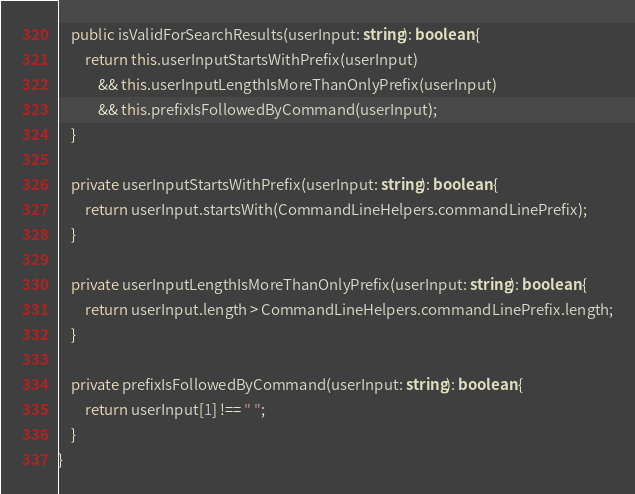<code> <loc_0><loc_0><loc_500><loc_500><_TypeScript_>    public isValidForSearchResults(userInput: string): boolean {
        return this.userInputStartsWithPrefix(userInput)
            && this.userInputLengthIsMoreThanOnlyPrefix(userInput)
            && this.prefixIsFollowedByCommand(userInput);
    }

    private userInputStartsWithPrefix(userInput: string): boolean {
        return userInput.startsWith(CommandLineHelpers.commandLinePrefix);
    }

    private userInputLengthIsMoreThanOnlyPrefix(userInput: string): boolean {
        return userInput.length > CommandLineHelpers.commandLinePrefix.length;
    }

    private prefixIsFollowedByCommand(userInput: string): boolean {
        return userInput[1] !== " ";
    }
}
</code> 